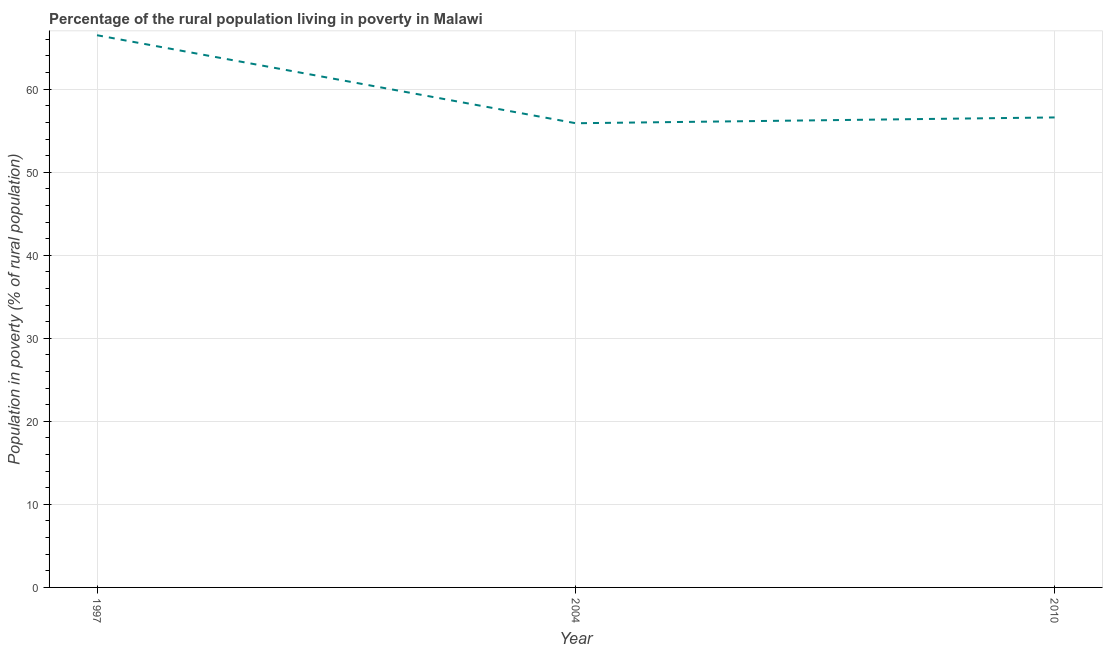What is the percentage of rural population living below poverty line in 2004?
Ensure brevity in your answer.  55.9. Across all years, what is the maximum percentage of rural population living below poverty line?
Provide a short and direct response. 66.5. Across all years, what is the minimum percentage of rural population living below poverty line?
Provide a short and direct response. 55.9. In which year was the percentage of rural population living below poverty line maximum?
Keep it short and to the point. 1997. In which year was the percentage of rural population living below poverty line minimum?
Keep it short and to the point. 2004. What is the sum of the percentage of rural population living below poverty line?
Your answer should be compact. 179. What is the difference between the percentage of rural population living below poverty line in 1997 and 2010?
Your response must be concise. 9.9. What is the average percentage of rural population living below poverty line per year?
Keep it short and to the point. 59.67. What is the median percentage of rural population living below poverty line?
Keep it short and to the point. 56.6. What is the ratio of the percentage of rural population living below poverty line in 1997 to that in 2004?
Provide a short and direct response. 1.19. Is the difference between the percentage of rural population living below poverty line in 1997 and 2010 greater than the difference between any two years?
Keep it short and to the point. No. What is the difference between the highest and the second highest percentage of rural population living below poverty line?
Provide a succinct answer. 9.9. Is the sum of the percentage of rural population living below poverty line in 1997 and 2004 greater than the maximum percentage of rural population living below poverty line across all years?
Offer a terse response. Yes. What is the difference between the highest and the lowest percentage of rural population living below poverty line?
Provide a succinct answer. 10.6. In how many years, is the percentage of rural population living below poverty line greater than the average percentage of rural population living below poverty line taken over all years?
Your answer should be compact. 1. How many years are there in the graph?
Your answer should be compact. 3. Are the values on the major ticks of Y-axis written in scientific E-notation?
Your answer should be very brief. No. Does the graph contain grids?
Provide a short and direct response. Yes. What is the title of the graph?
Your answer should be compact. Percentage of the rural population living in poverty in Malawi. What is the label or title of the X-axis?
Keep it short and to the point. Year. What is the label or title of the Y-axis?
Your answer should be compact. Population in poverty (% of rural population). What is the Population in poverty (% of rural population) in 1997?
Your response must be concise. 66.5. What is the Population in poverty (% of rural population) of 2004?
Make the answer very short. 55.9. What is the Population in poverty (% of rural population) in 2010?
Offer a very short reply. 56.6. What is the difference between the Population in poverty (% of rural population) in 1997 and 2004?
Offer a very short reply. 10.6. What is the difference between the Population in poverty (% of rural population) in 1997 and 2010?
Your answer should be compact. 9.9. What is the ratio of the Population in poverty (% of rural population) in 1997 to that in 2004?
Make the answer very short. 1.19. What is the ratio of the Population in poverty (% of rural population) in 1997 to that in 2010?
Your response must be concise. 1.18. 